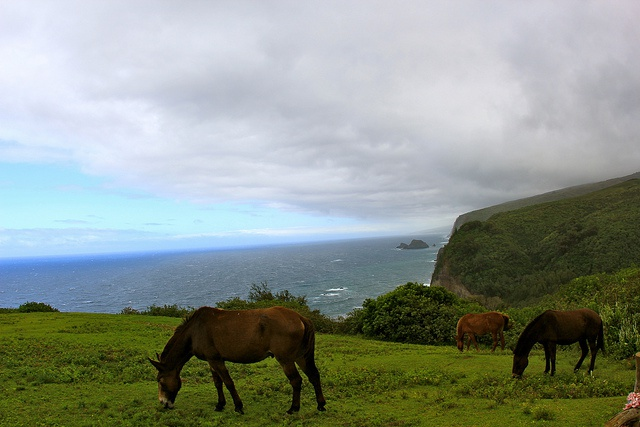Describe the objects in this image and their specific colors. I can see horse in lavender, black, maroon, olive, and darkgreen tones, horse in lavender, black, darkgreen, and maroon tones, and horse in lavender, black, maroon, and olive tones in this image. 